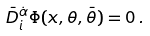Convert formula to latex. <formula><loc_0><loc_0><loc_500><loc_500>\bar { D } _ { i } ^ { \dot { \alpha } } \Phi ( x , \theta , \bar { \theta } ) = 0 \, .</formula> 